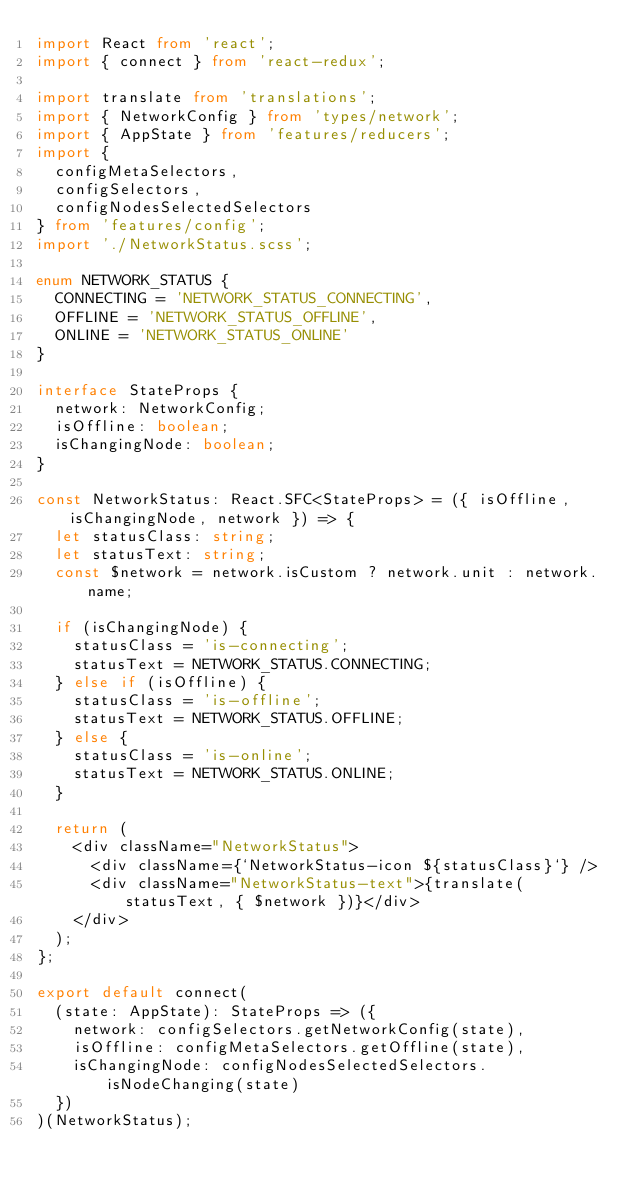Convert code to text. <code><loc_0><loc_0><loc_500><loc_500><_TypeScript_>import React from 'react';
import { connect } from 'react-redux';

import translate from 'translations';
import { NetworkConfig } from 'types/network';
import { AppState } from 'features/reducers';
import {
  configMetaSelectors,
  configSelectors,
  configNodesSelectedSelectors
} from 'features/config';
import './NetworkStatus.scss';

enum NETWORK_STATUS {
  CONNECTING = 'NETWORK_STATUS_CONNECTING',
  OFFLINE = 'NETWORK_STATUS_OFFLINE',
  ONLINE = 'NETWORK_STATUS_ONLINE'
}

interface StateProps {
  network: NetworkConfig;
  isOffline: boolean;
  isChangingNode: boolean;
}

const NetworkStatus: React.SFC<StateProps> = ({ isOffline, isChangingNode, network }) => {
  let statusClass: string;
  let statusText: string;
  const $network = network.isCustom ? network.unit : network.name;

  if (isChangingNode) {
    statusClass = 'is-connecting';
    statusText = NETWORK_STATUS.CONNECTING;
  } else if (isOffline) {
    statusClass = 'is-offline';
    statusText = NETWORK_STATUS.OFFLINE;
  } else {
    statusClass = 'is-online';
    statusText = NETWORK_STATUS.ONLINE;
  }

  return (
    <div className="NetworkStatus">
      <div className={`NetworkStatus-icon ${statusClass}`} />
      <div className="NetworkStatus-text">{translate(statusText, { $network })}</div>
    </div>
  );
};

export default connect(
  (state: AppState): StateProps => ({
    network: configSelectors.getNetworkConfig(state),
    isOffline: configMetaSelectors.getOffline(state),
    isChangingNode: configNodesSelectedSelectors.isNodeChanging(state)
  })
)(NetworkStatus);
</code> 